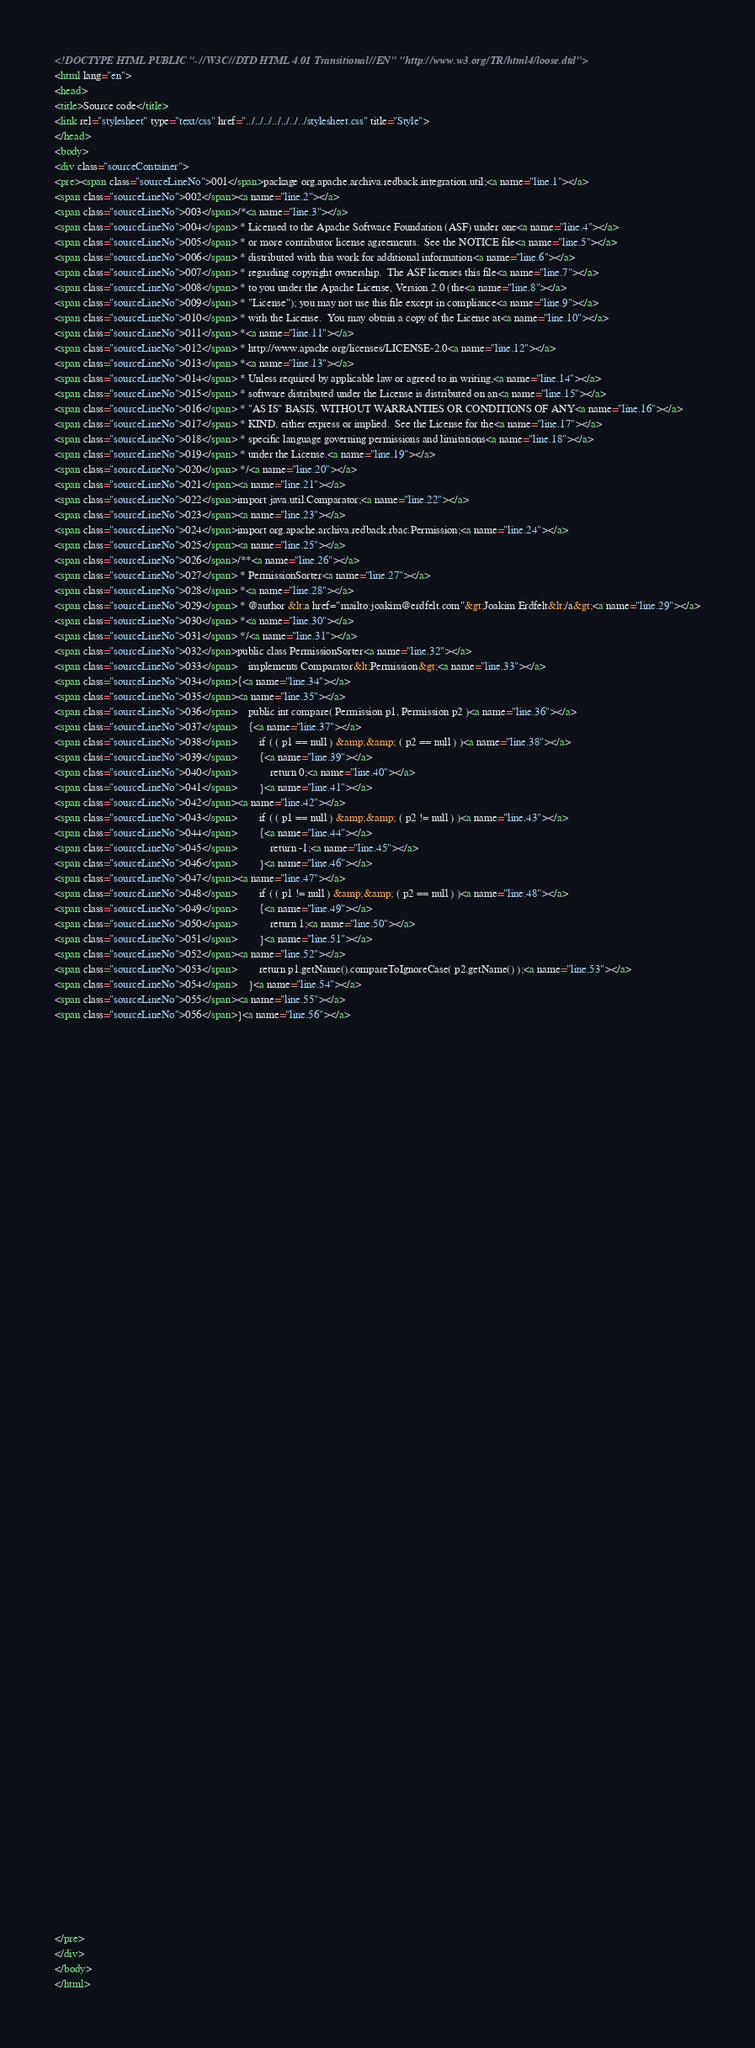Convert code to text. <code><loc_0><loc_0><loc_500><loc_500><_HTML_><!DOCTYPE HTML PUBLIC "-//W3C//DTD HTML 4.01 Transitional//EN" "http://www.w3.org/TR/html4/loose.dtd">
<html lang="en">
<head>
<title>Source code</title>
<link rel="stylesheet" type="text/css" href="../../../../../../../stylesheet.css" title="Style">
</head>
<body>
<div class="sourceContainer">
<pre><span class="sourceLineNo">001</span>package org.apache.archiva.redback.integration.util;<a name="line.1"></a>
<span class="sourceLineNo">002</span><a name="line.2"></a>
<span class="sourceLineNo">003</span>/*<a name="line.3"></a>
<span class="sourceLineNo">004</span> * Licensed to the Apache Software Foundation (ASF) under one<a name="line.4"></a>
<span class="sourceLineNo">005</span> * or more contributor license agreements.  See the NOTICE file<a name="line.5"></a>
<span class="sourceLineNo">006</span> * distributed with this work for additional information<a name="line.6"></a>
<span class="sourceLineNo">007</span> * regarding copyright ownership.  The ASF licenses this file<a name="line.7"></a>
<span class="sourceLineNo">008</span> * to you under the Apache License, Version 2.0 (the<a name="line.8"></a>
<span class="sourceLineNo">009</span> * "License"); you may not use this file except in compliance<a name="line.9"></a>
<span class="sourceLineNo">010</span> * with the License.  You may obtain a copy of the License at<a name="line.10"></a>
<span class="sourceLineNo">011</span> *<a name="line.11"></a>
<span class="sourceLineNo">012</span> * http://www.apache.org/licenses/LICENSE-2.0<a name="line.12"></a>
<span class="sourceLineNo">013</span> *<a name="line.13"></a>
<span class="sourceLineNo">014</span> * Unless required by applicable law or agreed to in writing,<a name="line.14"></a>
<span class="sourceLineNo">015</span> * software distributed under the License is distributed on an<a name="line.15"></a>
<span class="sourceLineNo">016</span> * "AS IS" BASIS, WITHOUT WARRANTIES OR CONDITIONS OF ANY<a name="line.16"></a>
<span class="sourceLineNo">017</span> * KIND, either express or implied.  See the License for the<a name="line.17"></a>
<span class="sourceLineNo">018</span> * specific language governing permissions and limitations<a name="line.18"></a>
<span class="sourceLineNo">019</span> * under the License.<a name="line.19"></a>
<span class="sourceLineNo">020</span> */<a name="line.20"></a>
<span class="sourceLineNo">021</span><a name="line.21"></a>
<span class="sourceLineNo">022</span>import java.util.Comparator;<a name="line.22"></a>
<span class="sourceLineNo">023</span><a name="line.23"></a>
<span class="sourceLineNo">024</span>import org.apache.archiva.redback.rbac.Permission;<a name="line.24"></a>
<span class="sourceLineNo">025</span><a name="line.25"></a>
<span class="sourceLineNo">026</span>/**<a name="line.26"></a>
<span class="sourceLineNo">027</span> * PermissionSorter<a name="line.27"></a>
<span class="sourceLineNo">028</span> *<a name="line.28"></a>
<span class="sourceLineNo">029</span> * @author &lt;a href="mailto:joakim@erdfelt.com"&gt;Joakim Erdfelt&lt;/a&gt;<a name="line.29"></a>
<span class="sourceLineNo">030</span> *<a name="line.30"></a>
<span class="sourceLineNo">031</span> */<a name="line.31"></a>
<span class="sourceLineNo">032</span>public class PermissionSorter<a name="line.32"></a>
<span class="sourceLineNo">033</span>    implements Comparator&lt;Permission&gt;<a name="line.33"></a>
<span class="sourceLineNo">034</span>{<a name="line.34"></a>
<span class="sourceLineNo">035</span><a name="line.35"></a>
<span class="sourceLineNo">036</span>    public int compare( Permission p1, Permission p2 )<a name="line.36"></a>
<span class="sourceLineNo">037</span>    {<a name="line.37"></a>
<span class="sourceLineNo">038</span>        if ( ( p1 == null ) &amp;&amp; ( p2 == null ) )<a name="line.38"></a>
<span class="sourceLineNo">039</span>        {<a name="line.39"></a>
<span class="sourceLineNo">040</span>            return 0;<a name="line.40"></a>
<span class="sourceLineNo">041</span>        }<a name="line.41"></a>
<span class="sourceLineNo">042</span><a name="line.42"></a>
<span class="sourceLineNo">043</span>        if ( ( p1 == null ) &amp;&amp; ( p2 != null ) )<a name="line.43"></a>
<span class="sourceLineNo">044</span>        {<a name="line.44"></a>
<span class="sourceLineNo">045</span>            return -1;<a name="line.45"></a>
<span class="sourceLineNo">046</span>        }<a name="line.46"></a>
<span class="sourceLineNo">047</span><a name="line.47"></a>
<span class="sourceLineNo">048</span>        if ( ( p1 != null ) &amp;&amp; ( p2 == null ) )<a name="line.48"></a>
<span class="sourceLineNo">049</span>        {<a name="line.49"></a>
<span class="sourceLineNo">050</span>            return 1;<a name="line.50"></a>
<span class="sourceLineNo">051</span>        }<a name="line.51"></a>
<span class="sourceLineNo">052</span><a name="line.52"></a>
<span class="sourceLineNo">053</span>        return p1.getName().compareToIgnoreCase( p2.getName() );<a name="line.53"></a>
<span class="sourceLineNo">054</span>    }<a name="line.54"></a>
<span class="sourceLineNo">055</span><a name="line.55"></a>
<span class="sourceLineNo">056</span>}<a name="line.56"></a>




























































</pre>
</div>
</body>
</html></code> 